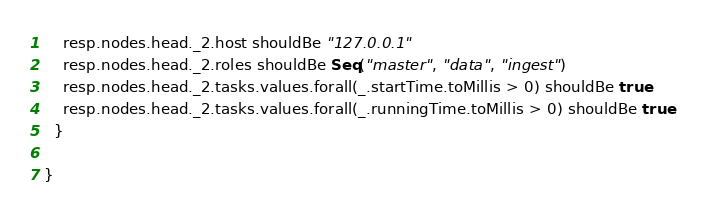Convert code to text. <code><loc_0><loc_0><loc_500><loc_500><_Scala_>
    resp.nodes.head._2.host shouldBe "127.0.0.1"
    resp.nodes.head._2.roles shouldBe Seq("master", "data", "ingest")
    resp.nodes.head._2.tasks.values.forall(_.startTime.toMillis > 0) shouldBe true
    resp.nodes.head._2.tasks.values.forall(_.runningTime.toMillis > 0) shouldBe true
  }

}
</code> 